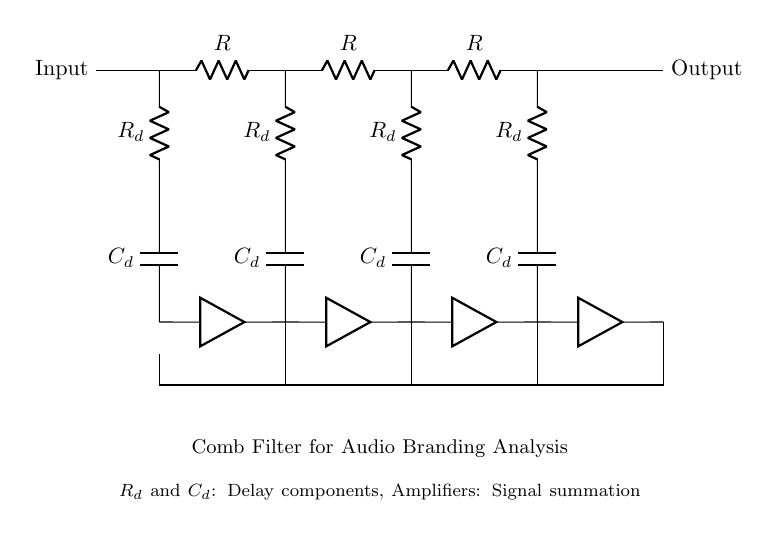What type of filter is represented in the circuit? The diagram represents a comb filter, which is identified by the multiple delay lines and feedback structure that creates specific frequency enhancing characteristics.
Answer: Comb filter How many resistors are present in the circuit? The circuit diagram shows three resistors in the main path along with additional resistors that are part of the delay lines and summing amplifiers, totaling five resistors overall.
Answer: Five What does the symbol labeled as 'C' represent in this circuit? The 'C' in the diagram represents a capacitor, which is typically used in filters to store and release electrical energy, contributing to the filtering process by affecting the phase of certain frequencies.
Answer: Capacitor What is the function of the delay components in this comb filter? The delay components, which include resistors and capacitors, are responsible for introducing time delays between the input and output signals, thus creating the characteristic notches (gaps in frequency response) of the comb filter.
Answer: Introduce time delays What is the purpose of the feedback paths shown in the circuit? The feedback paths are used to route the output signal back into the system, allowing the filter to combine the delayed signals with the input, which enhances specific frequency components while attenuating others, crucial for sonic branding analyses.
Answer: Enhance specific frequencies How does the number of delay lines affect the filter response? The response of a comb filter is directly influenced by the number of delay lines; more delay lines can create a more complex frequency pattern with more notches, thus altering how the filter interacts with audio frequencies, impacting the consumer's perception of sound.
Answer: More delay lines create more notches What role do the amplifiers play in this circuit? The amplifiers in the circuit serve to strengthen the signals after they have been delayed, ensuring that the output retains sufficient power and clarity, thus influencing the effectiveness of the sonic branding and audio branding efforts.
Answer: Strengthen the signals 